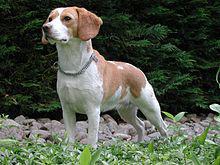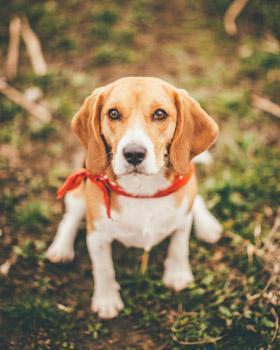The first image is the image on the left, the second image is the image on the right. Analyze the images presented: Is the assertion "There is at least one puppy in one of the pictures." valid? Answer yes or no. No. The first image is the image on the left, the second image is the image on the right. Evaluate the accuracy of this statement regarding the images: "a beagle sitting in the grass has dog tags on it's collar". Is it true? Answer yes or no. No. 